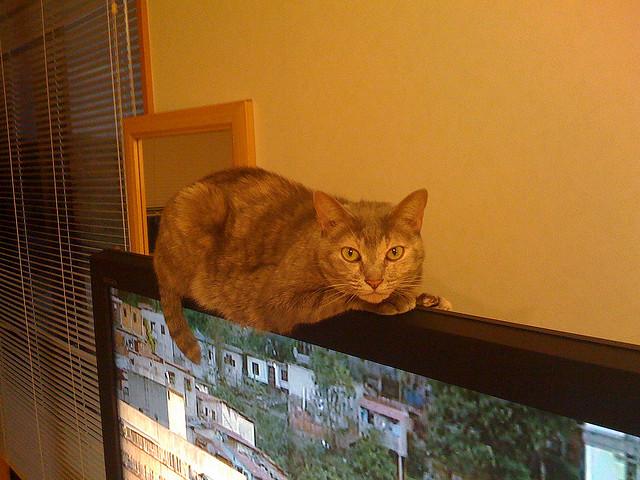How many stripes can be seen on the cat's tail?
Answer briefly. 4. How many cats do you see?
Give a very brief answer. 1. What color is the cat?
Keep it brief. Gray. Is the cat looking at the camera?
Give a very brief answer. Yes. What do you think this cat's name is?
Short answer required. Don't know. What plants are on the television?
Give a very brief answer. Trees. 